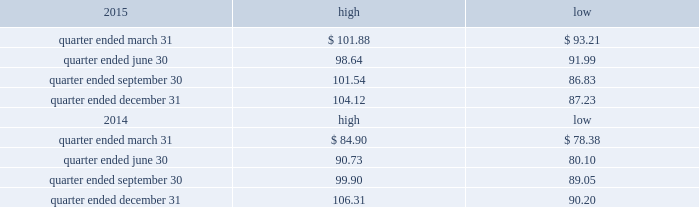Part ii item 5 .
Market for registrant 2019s common equity , related stockholder matters and issuer purchases of equity securities the table presents reported quarterly high and low per share sale prices of our common stock on the nyse for the years 2015 and 2014. .
On february 19 , 2016 , the closing price of our common stock was $ 87.32 per share as reported on the nyse .
As of february 19 , 2016 , we had 423897556 outstanding shares of common stock and 159 registered holders .
Dividends as a reit , we must annually distribute to our stockholders an amount equal to at least 90% ( 90 % ) of our reit taxable income ( determined before the deduction for distributed earnings and excluding any net capital gain ) .
Generally , we have distributed and expect to continue to distribute all or substantially all of our reit taxable income after taking into consideration our utilization of net operating losses ( 201cnols 201d ) .
We have two series of preferred stock outstanding , 5.25% ( 5.25 % ) mandatory convertible preferred stock , series a , issued in may 2014 ( the 201cseries a preferred stock 201d ) , with a dividend rate of 5.25% ( 5.25 % ) , and the 5.50% ( 5.50 % ) mandatory convertible preferred stock , series b ( the 201cseries b preferred stock 201d ) , issued in march 2015 , with a dividend rate of 5.50% ( 5.50 % ) .
Dividends are payable quarterly in arrears , subject to declaration by our board of directors .
The amount , timing and frequency of future distributions will be at the sole discretion of our board of directors and will be dependent upon various factors , a number of which may be beyond our control , including our financial condition and operating cash flows , the amount required to maintain our qualification for taxation as a reit and reduce any income and excise taxes that we otherwise would be required to pay , limitations on distributions in our existing and future debt and preferred equity instruments , our ability to utilize nols to offset our distribution requirements , limitations on our ability to fund distributions using cash generated through our trss and other factors that our board of directors may deem relevant .
We have distributed an aggregate of approximately $ 2.3 billion to our common stockholders , including the dividend paid in january 2016 , primarily subject to taxation as ordinary income .
During the year ended december 31 , 2015 , we declared the following cash distributions: .
For the= quarter ended march 31 what was the percent of the change in the stock price from the highest to the lowest? 
Computations: ((101.88 - 93.21) / 93.21)
Answer: 0.09302. Part ii item 5 .
Market for registrant 2019s common equity , related stockholder matters and issuer purchases of equity securities the table presents reported quarterly high and low per share sale prices of our common stock on the nyse for the years 2015 and 2014. .
On february 19 , 2016 , the closing price of our common stock was $ 87.32 per share as reported on the nyse .
As of february 19 , 2016 , we had 423897556 outstanding shares of common stock and 159 registered holders .
Dividends as a reit , we must annually distribute to our stockholders an amount equal to at least 90% ( 90 % ) of our reit taxable income ( determined before the deduction for distributed earnings and excluding any net capital gain ) .
Generally , we have distributed and expect to continue to distribute all or substantially all of our reit taxable income after taking into consideration our utilization of net operating losses ( 201cnols 201d ) .
We have two series of preferred stock outstanding , 5.25% ( 5.25 % ) mandatory convertible preferred stock , series a , issued in may 2014 ( the 201cseries a preferred stock 201d ) , with a dividend rate of 5.25% ( 5.25 % ) , and the 5.50% ( 5.50 % ) mandatory convertible preferred stock , series b ( the 201cseries b preferred stock 201d ) , issued in march 2015 , with a dividend rate of 5.50% ( 5.50 % ) .
Dividends are payable quarterly in arrears , subject to declaration by our board of directors .
The amount , timing and frequency of future distributions will be at the sole discretion of our board of directors and will be dependent upon various factors , a number of which may be beyond our control , including our financial condition and operating cash flows , the amount required to maintain our qualification for taxation as a reit and reduce any income and excise taxes that we otherwise would be required to pay , limitations on distributions in our existing and future debt and preferred equity instruments , our ability to utilize nols to offset our distribution requirements , limitations on our ability to fund distributions using cash generated through our trss and other factors that our board of directors may deem relevant .
We have distributed an aggregate of approximately $ 2.3 billion to our common stockholders , including the dividend paid in january 2016 , primarily subject to taxation as ordinary income .
During the year ended december 31 , 2015 , we declared the following cash distributions: .
As of february 19 , 2016 what was the market capitalization? 
Computations: (423897556 * 87.32)
Answer: 37014734589.92. 